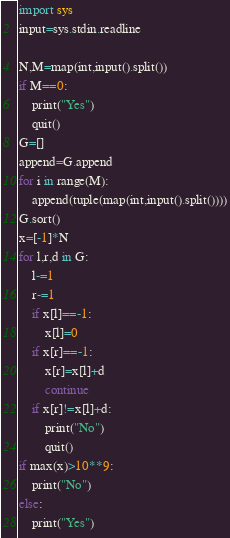<code> <loc_0><loc_0><loc_500><loc_500><_Python_>import sys
input=sys.stdin.readline

N,M=map(int,input().split())
if M==0:
    print("Yes")
    quit()
G=[]
append=G.append
for i in range(M):
    append(tuple(map(int,input().split())))
G.sort()
x=[-1]*N
for l,r,d in G:
    l-=1
    r-=1
    if x[l]==-1:
        x[l]=0
    if x[r]==-1:
        x[r]=x[l]+d
        continue
    if x[r]!=x[l]+d:
        print("No")
        quit()
if max(x)>10**9:
    print("No")
else:
    print("Yes")
</code> 